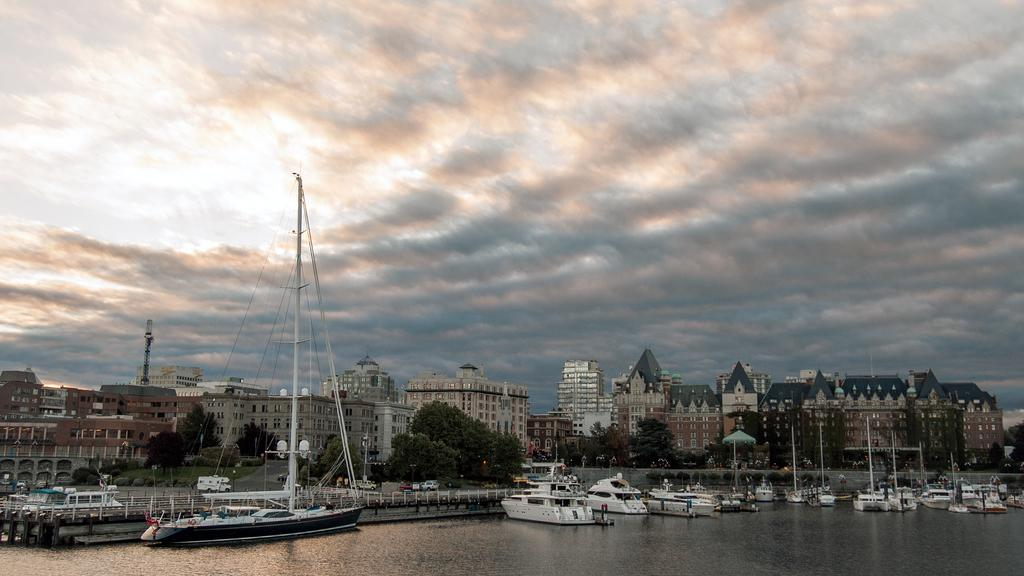What can be seen in the foreground of the image? There are boats on the water body in the foreground. What is present in the image that separates different areas or provides a barrier? There is a fence in the image. What can be seen in the background of the image? There are buildings and trees in the background. How would you describe the sky in the image? The sky is cloudy in the image. What type of flesh can be seen hanging from the boats in the image? There is no flesh present in the image; it features boats on a water body with a fence, buildings, trees, and a cloudy sky. What kind of glue is used to attach the sails to the boats in the image? There are no sails or glue mentioned in the image; it only shows boats on a water body, a fence, buildings, trees, and a cloudy sky. 